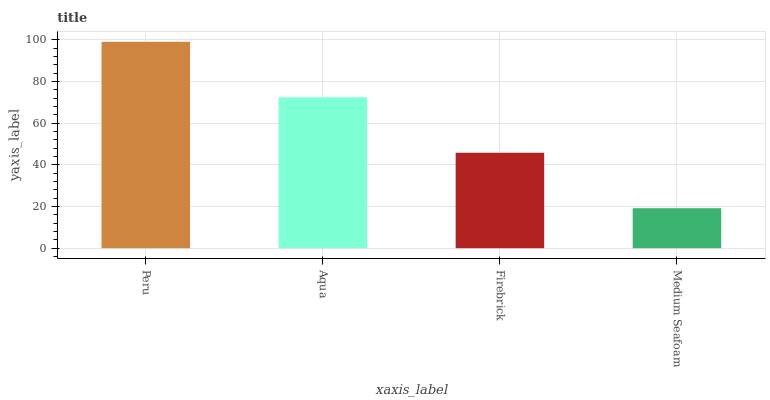Is Medium Seafoam the minimum?
Answer yes or no. Yes. Is Peru the maximum?
Answer yes or no. Yes. Is Aqua the minimum?
Answer yes or no. No. Is Aqua the maximum?
Answer yes or no. No. Is Peru greater than Aqua?
Answer yes or no. Yes. Is Aqua less than Peru?
Answer yes or no. Yes. Is Aqua greater than Peru?
Answer yes or no. No. Is Peru less than Aqua?
Answer yes or no. No. Is Aqua the high median?
Answer yes or no. Yes. Is Firebrick the low median?
Answer yes or no. Yes. Is Medium Seafoam the high median?
Answer yes or no. No. Is Medium Seafoam the low median?
Answer yes or no. No. 